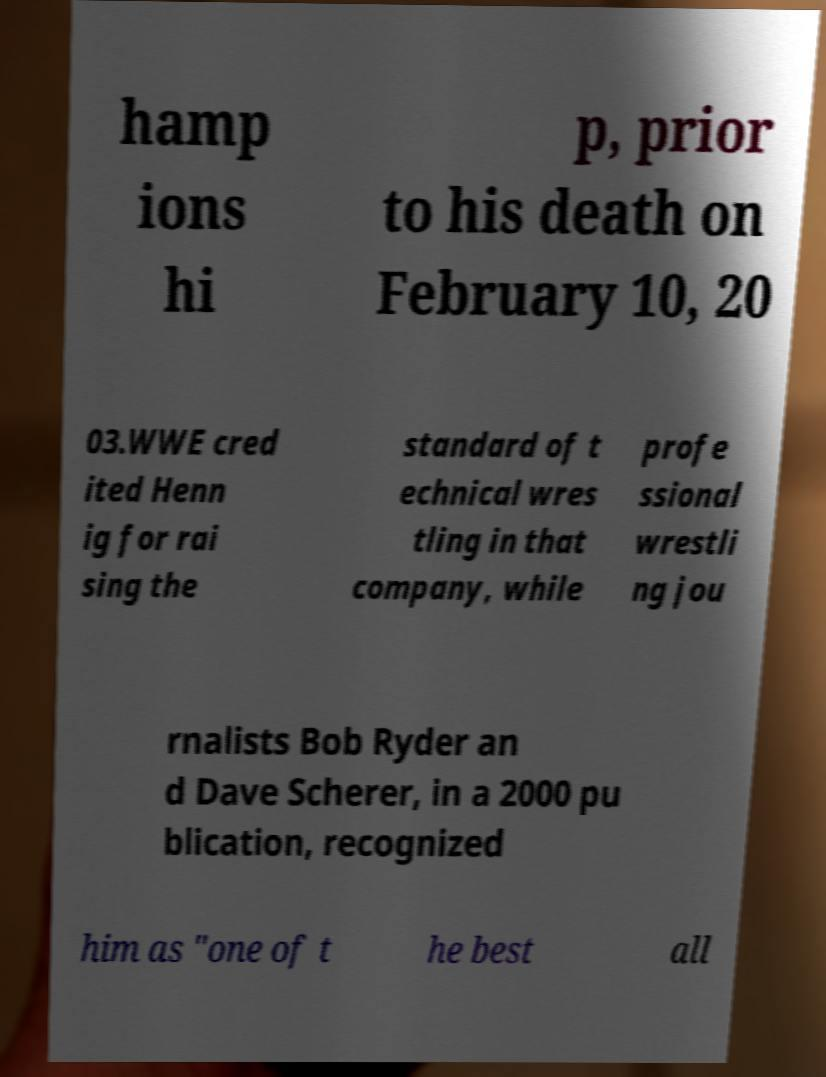Could you extract and type out the text from this image? hamp ions hi p, prior to his death on February 10, 20 03.WWE cred ited Henn ig for rai sing the standard of t echnical wres tling in that company, while profe ssional wrestli ng jou rnalists Bob Ryder an d Dave Scherer, in a 2000 pu blication, recognized him as "one of t he best all 